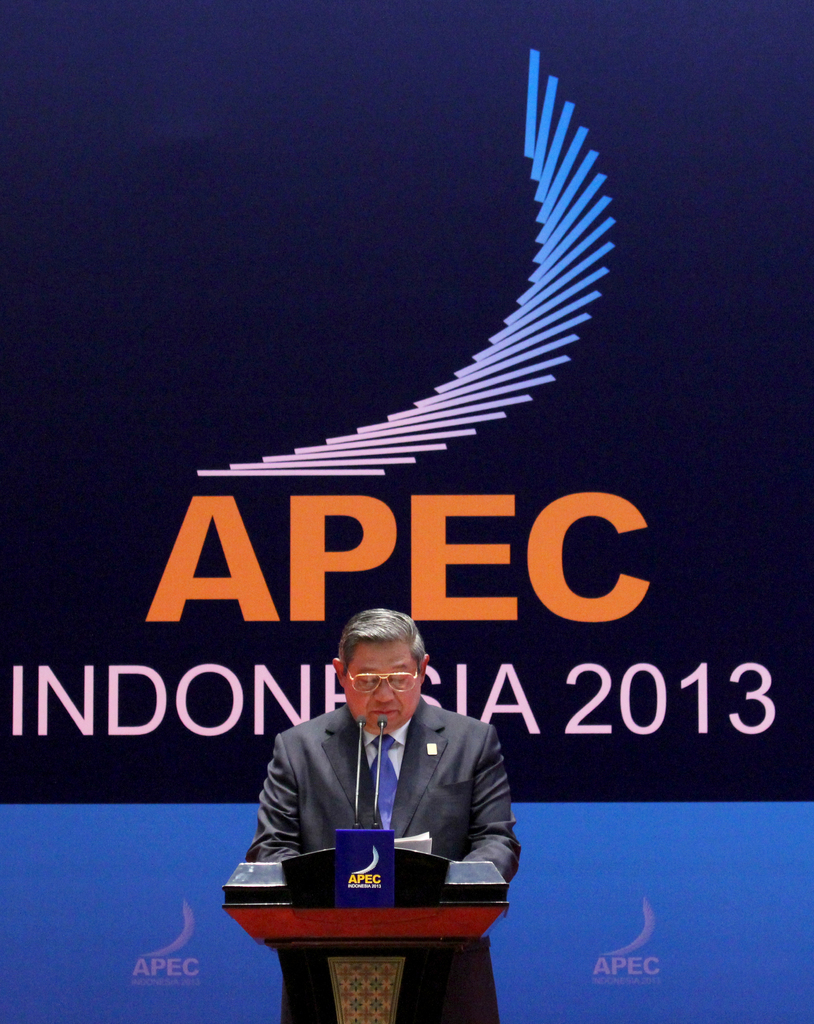What can you infer about the audience's reaction just from the speaker's body language? The speaker exhibits a posture of seriousness and determination, which could suggest that his message is of considerable importance and gravity to the audience. His focus and the attention to the microphone indicate a careful delivery, typically eliciting a respectful and attentive response from the audience. 